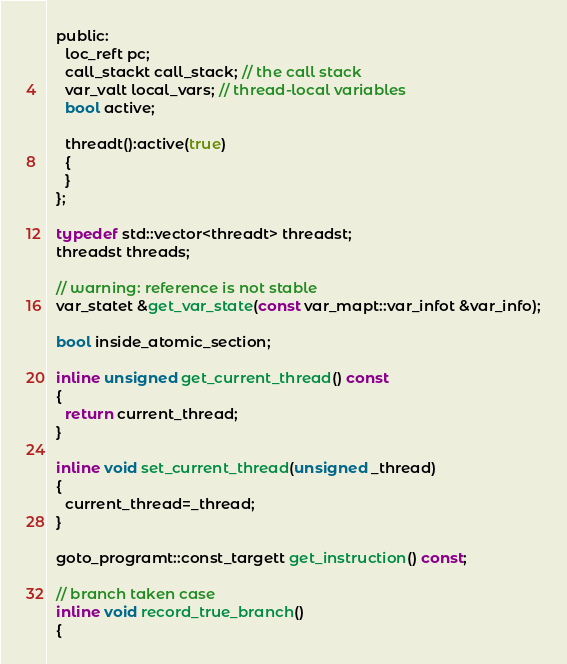Convert code to text. <code><loc_0><loc_0><loc_500><loc_500><_C_>  public:
    loc_reft pc;
    call_stackt call_stack; // the call stack
    var_valt local_vars; // thread-local variables
    bool active;

    threadt():active(true)
    {
    }
  };

  typedef std::vector<threadt> threadst;
  threadst threads;

  // warning: reference is not stable
  var_statet &get_var_state(const var_mapt::var_infot &var_info);

  bool inside_atomic_section;

  inline unsigned get_current_thread() const
  {
    return current_thread;
  }

  inline void set_current_thread(unsigned _thread)
  {
    current_thread=_thread;
  }

  goto_programt::const_targett get_instruction() const;

  // branch taken case
  inline void record_true_branch()
  {</code> 